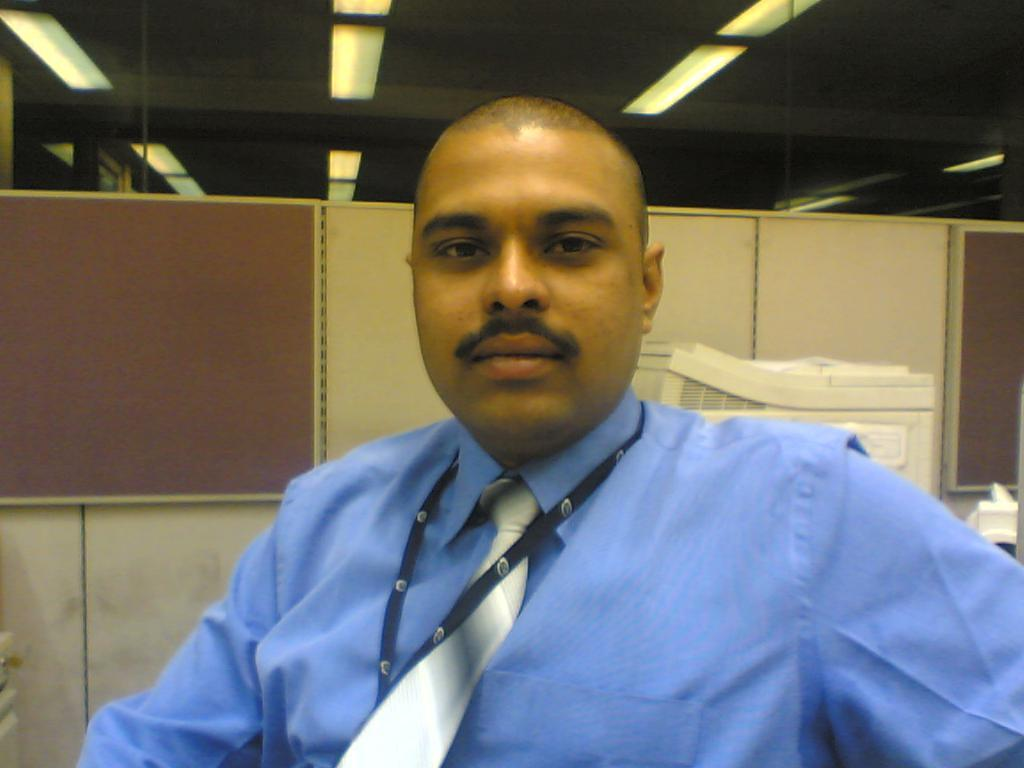What is the man in the image doing? The man is sitting in the image. What can be seen in the background of the image? There is a xerox machine and a wall in the background of the image. What is the source of illumination in the image? There are lights on the ceiling in the image. What type of weather can be seen through the window in the image? There is no window or weather mentioned in the image; it only features a man sitting, a xerox machine, a wall, and lights on the ceiling. 